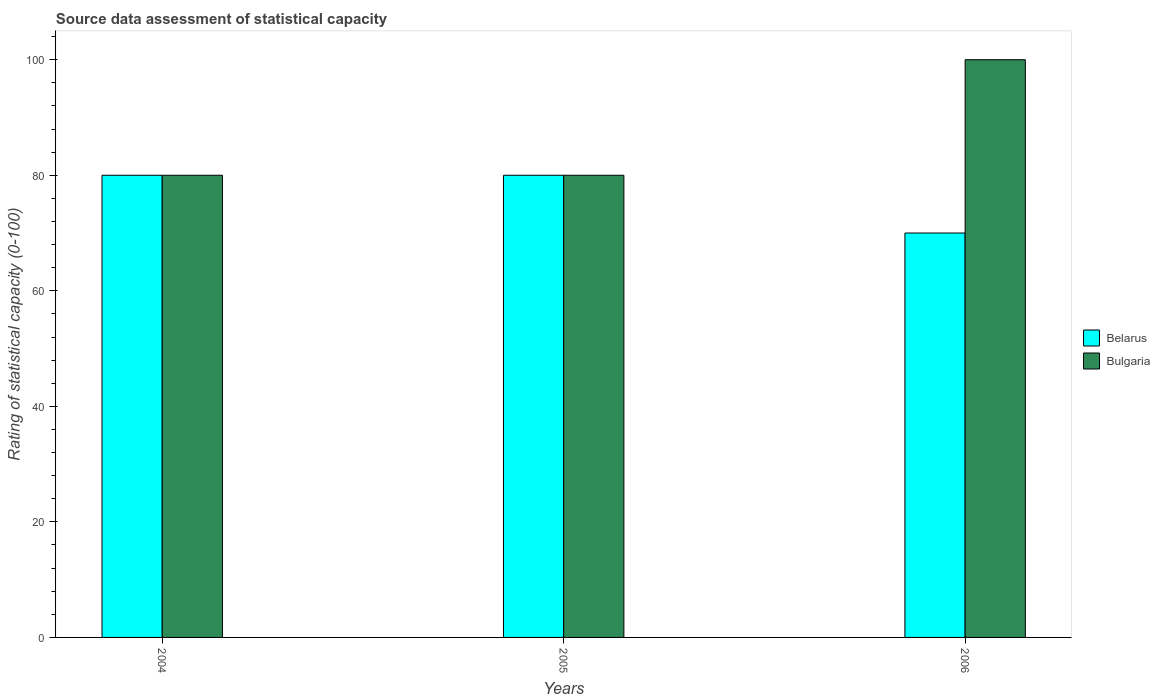How many groups of bars are there?
Offer a very short reply. 3. Are the number of bars on each tick of the X-axis equal?
Provide a short and direct response. Yes. What is the rating of statistical capacity in Bulgaria in 2004?
Give a very brief answer. 80. Across all years, what is the maximum rating of statistical capacity in Belarus?
Your response must be concise. 80. Across all years, what is the minimum rating of statistical capacity in Belarus?
Offer a very short reply. 70. What is the total rating of statistical capacity in Belarus in the graph?
Give a very brief answer. 230. What is the difference between the rating of statistical capacity in Bulgaria in 2004 and that in 2006?
Make the answer very short. -20. What is the difference between the rating of statistical capacity in Belarus in 2005 and the rating of statistical capacity in Bulgaria in 2006?
Provide a succinct answer. -20. What is the average rating of statistical capacity in Belarus per year?
Make the answer very short. 76.67. In how many years, is the rating of statistical capacity in Belarus greater than 44?
Offer a very short reply. 3. Is the rating of statistical capacity in Belarus in 2005 less than that in 2006?
Your answer should be very brief. No. Is the difference between the rating of statistical capacity in Belarus in 2005 and 2006 greater than the difference between the rating of statistical capacity in Bulgaria in 2005 and 2006?
Keep it short and to the point. Yes. What is the difference between the highest and the second highest rating of statistical capacity in Belarus?
Offer a terse response. 0. What is the difference between the highest and the lowest rating of statistical capacity in Bulgaria?
Your answer should be compact. 20. In how many years, is the rating of statistical capacity in Belarus greater than the average rating of statistical capacity in Belarus taken over all years?
Make the answer very short. 2. Is the sum of the rating of statistical capacity in Bulgaria in 2004 and 2005 greater than the maximum rating of statistical capacity in Belarus across all years?
Your answer should be compact. Yes. What does the 1st bar from the right in 2006 represents?
Offer a terse response. Bulgaria. How many bars are there?
Your answer should be very brief. 6. Are all the bars in the graph horizontal?
Your answer should be very brief. No. How many years are there in the graph?
Your answer should be very brief. 3. Are the values on the major ticks of Y-axis written in scientific E-notation?
Provide a succinct answer. No. Does the graph contain any zero values?
Keep it short and to the point. No. Does the graph contain grids?
Make the answer very short. No. How are the legend labels stacked?
Ensure brevity in your answer.  Vertical. What is the title of the graph?
Your answer should be compact. Source data assessment of statistical capacity. What is the label or title of the X-axis?
Your answer should be compact. Years. What is the label or title of the Y-axis?
Give a very brief answer. Rating of statistical capacity (0-100). What is the Rating of statistical capacity (0-100) in Bulgaria in 2005?
Your answer should be very brief. 80. What is the Rating of statistical capacity (0-100) in Bulgaria in 2006?
Offer a very short reply. 100. Across all years, what is the maximum Rating of statistical capacity (0-100) of Bulgaria?
Offer a terse response. 100. Across all years, what is the minimum Rating of statistical capacity (0-100) of Bulgaria?
Ensure brevity in your answer.  80. What is the total Rating of statistical capacity (0-100) in Belarus in the graph?
Provide a succinct answer. 230. What is the total Rating of statistical capacity (0-100) of Bulgaria in the graph?
Provide a succinct answer. 260. What is the difference between the Rating of statistical capacity (0-100) of Belarus in 2004 and that in 2006?
Your response must be concise. 10. What is the difference between the Rating of statistical capacity (0-100) in Belarus in 2005 and the Rating of statistical capacity (0-100) in Bulgaria in 2006?
Provide a short and direct response. -20. What is the average Rating of statistical capacity (0-100) of Belarus per year?
Offer a very short reply. 76.67. What is the average Rating of statistical capacity (0-100) of Bulgaria per year?
Offer a very short reply. 86.67. In the year 2006, what is the difference between the Rating of statistical capacity (0-100) in Belarus and Rating of statistical capacity (0-100) in Bulgaria?
Provide a succinct answer. -30. What is the ratio of the Rating of statistical capacity (0-100) in Belarus in 2004 to that in 2005?
Your answer should be compact. 1. What is the ratio of the Rating of statistical capacity (0-100) of Bulgaria in 2004 to that in 2005?
Ensure brevity in your answer.  1. What is the ratio of the Rating of statistical capacity (0-100) of Bulgaria in 2005 to that in 2006?
Give a very brief answer. 0.8. What is the difference between the highest and the second highest Rating of statistical capacity (0-100) of Belarus?
Ensure brevity in your answer.  0. What is the difference between the highest and the second highest Rating of statistical capacity (0-100) of Bulgaria?
Your response must be concise. 20. What is the difference between the highest and the lowest Rating of statistical capacity (0-100) in Belarus?
Your answer should be compact. 10. 